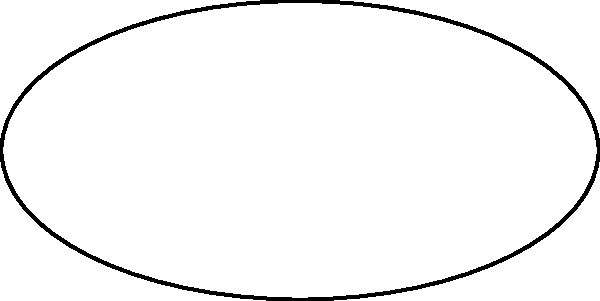As a former linebacker, you're familiar with the shape of a football. Compare the curvature of a football to that of a hyperbolic surface. Which surface has positive curvature, and which has negative curvature? How does this relate to the way these objects behave when rolled on a flat surface? Let's break this down step-by-step:

1. Curvature in geometry:
   - Positive curvature: Surface curves outward (like a sphere)
   - Negative curvature: Surface curves inward (like a saddle)

2. Football shape:
   - A football is a prolate spheroid
   - It curves outward in all directions
   - Therefore, it has positive curvature

3. Hyperbolic surface:
   - Curves inward along one axis and outward along the perpendicular axis
   - This results in a saddle-like shape
   - Therefore, it has negative curvature

4. Rolling behavior:
   - Football (positive curvature):
     * When rolled on a flat surface, it tends to curve back towards its starting point
     * This is why a football doesn't roll in a straight line like a perfect sphere would

   - Hyperbolic surface (negative curvature):
     * If you could roll it, it would tend to veer away from its initial path
     * However, most hyperbolic surfaces can't be rolled easily due to their shape

5. Relation to Non-Euclidean Geometry:
   - The football represents a small portion of a positively curved space (like a sphere)
   - The hyperbolic surface represents a negatively curved space
   - Both of these are examples of Non-Euclidean geometries, where parallel lines can converge (positive curvature) or diverge (negative curvature)
Answer: Football: positive curvature; Hyperbolic surface: negative curvature. Football curves back when rolled; hyperbolic surface would veer away if rolled. 